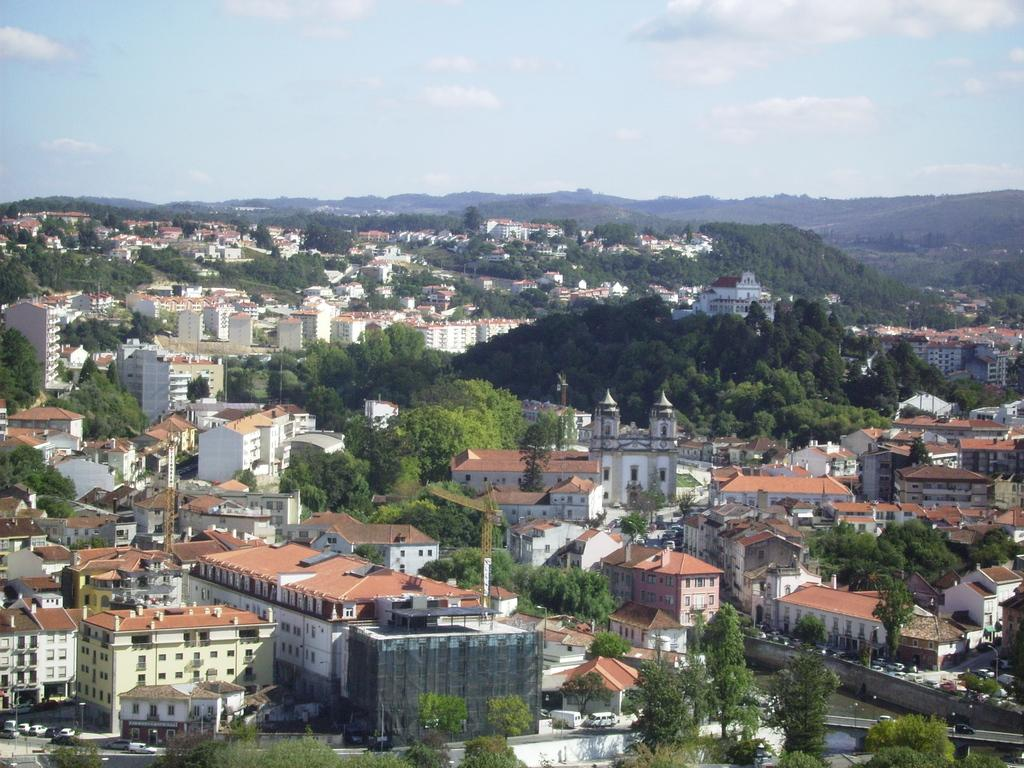What type of structures can be seen in the image? There are buildings in the image. What other natural elements are present in the image? There are trees in the image. What can be seen in the distance in the background of the image? Hills are visible in the background of the image. What is visible above the buildings and trees in the image? The sky is visible in the background of the image. What type of pot is being used to roll over the hills in the image? There is no pot or rolling activity present in the image. 